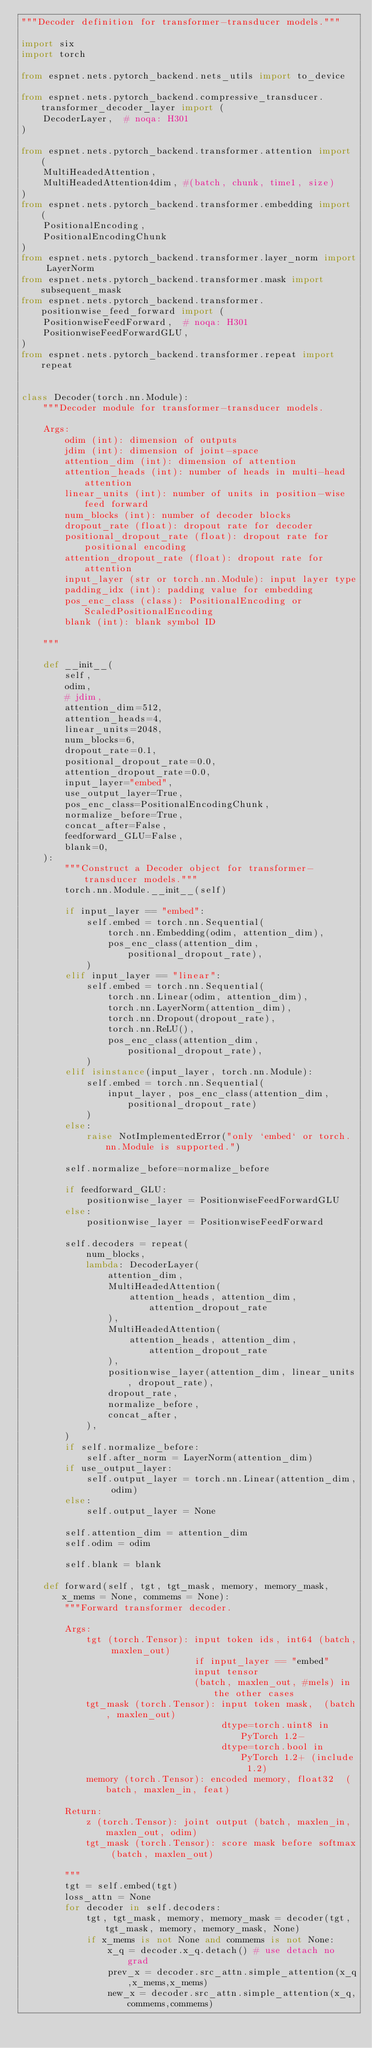<code> <loc_0><loc_0><loc_500><loc_500><_Python_>"""Decoder definition for transformer-transducer models."""

import six
import torch

from espnet.nets.pytorch_backend.nets_utils import to_device

from espnet.nets.pytorch_backend.compressive_transducer.transformer_decoder_layer import (
    DecoderLayer,  # noqa: H301
)

from espnet.nets.pytorch_backend.transformer.attention import (
    MultiHeadedAttention,
    MultiHeadedAttention4dim, #(batch, chunk, time1, size)
)
from espnet.nets.pytorch_backend.transformer.embedding import (
    PositionalEncoding,
    PositionalEncodingChunk
)
from espnet.nets.pytorch_backend.transformer.layer_norm import LayerNorm
from espnet.nets.pytorch_backend.transformer.mask import subsequent_mask
from espnet.nets.pytorch_backend.transformer.positionwise_feed_forward import (
    PositionwiseFeedForward,  # noqa: H301
    PositionwiseFeedForwardGLU,
)
from espnet.nets.pytorch_backend.transformer.repeat import repeat


class Decoder(torch.nn.Module):
    """Decoder module for transformer-transducer models.

    Args:
        odim (int): dimension of outputs
        jdim (int): dimension of joint-space
        attention_dim (int): dimension of attention
        attention_heads (int): number of heads in multi-head attention
        linear_units (int): number of units in position-wise feed forward
        num_blocks (int): number of decoder blocks
        dropout_rate (float): dropout rate for decoder
        positional_dropout_rate (float): dropout rate for positional encoding
        attention_dropout_rate (float): dropout rate for attention
        input_layer (str or torch.nn.Module): input layer type
        padding_idx (int): padding value for embedding
        pos_enc_class (class): PositionalEncoding or ScaledPositionalEncoding
        blank (int): blank symbol ID

    """

    def __init__(
        self,
        odim,
        # jdim,
        attention_dim=512,
        attention_heads=4,
        linear_units=2048,
        num_blocks=6,
        dropout_rate=0.1,
        positional_dropout_rate=0.0,
        attention_dropout_rate=0.0,
        input_layer="embed",
        use_output_layer=True,
        pos_enc_class=PositionalEncodingChunk,
        normalize_before=True,
        concat_after=False,
        feedforward_GLU=False,
        blank=0,
    ):
        """Construct a Decoder object for transformer-transducer models."""
        torch.nn.Module.__init__(self)

        if input_layer == "embed":
            self.embed = torch.nn.Sequential(
                torch.nn.Embedding(odim, attention_dim),
                pos_enc_class(attention_dim, positional_dropout_rate),
            )
        elif input_layer == "linear":
            self.embed = torch.nn.Sequential(
                torch.nn.Linear(odim, attention_dim),
                torch.nn.LayerNorm(attention_dim),
                torch.nn.Dropout(dropout_rate),
                torch.nn.ReLU(),
                pos_enc_class(attention_dim, positional_dropout_rate),
            )
        elif isinstance(input_layer, torch.nn.Module):
            self.embed = torch.nn.Sequential(
                input_layer, pos_enc_class(attention_dim, positional_dropout_rate)
            )
        else:
            raise NotImplementedError("only `embed` or torch.nn.Module is supported.")
        
        self.normalize_before=normalize_before

        if feedforward_GLU:
            positionwise_layer = PositionwiseFeedForwardGLU
        else:
            positionwise_layer = PositionwiseFeedForward

        self.decoders = repeat(
            num_blocks,
            lambda: DecoderLayer(
                attention_dim,
                MultiHeadedAttention(
                    attention_heads, attention_dim, attention_dropout_rate
                ),
                MultiHeadedAttention(
                    attention_heads, attention_dim, attention_dropout_rate
                ),
                positionwise_layer(attention_dim, linear_units, dropout_rate),
                dropout_rate,
                normalize_before,
                concat_after,
            ),
        )
        if self.normalize_before:
            self.after_norm = LayerNorm(attention_dim)
        if use_output_layer:
            self.output_layer = torch.nn.Linear(attention_dim, odim)
        else:
            self.output_layer = None

        self.attention_dim = attention_dim
        self.odim = odim

        self.blank = blank

    def forward(self, tgt, tgt_mask, memory, memory_mask, x_mems = None, commems = None):
        """Forward transformer decoder.

        Args:
            tgt (torch.Tensor): input token ids, int64 (batch, maxlen_out)
                                if input_layer == "embed"
                                input tensor
                                (batch, maxlen_out, #mels) in the other cases
            tgt_mask (torch.Tensor): input token mask,  (batch, maxlen_out)
                                     dtype=torch.uint8 in PyTorch 1.2-
                                     dtype=torch.bool in PyTorch 1.2+ (include 1.2)
            memory (torch.Tensor): encoded memory, float32  (batch, maxlen_in, feat)

        Return:
            z (torch.Tensor): joint output (batch, maxlen_in, maxlen_out, odim)
            tgt_mask (torch.Tensor): score mask before softmax (batch, maxlen_out)

        """
        tgt = self.embed(tgt)
        loss_attn = None
        for decoder in self.decoders:
            tgt, tgt_mask, memory, memory_mask = decoder(tgt, tgt_mask, memory, memory_mask, None) 
            if x_mems is not None and commems is not None:
                x_q = decoder.x_q.detach() # use detach no grad
                prev_x = decoder.src_attn.simple_attention(x_q,x_mems,x_mems)
                new_x = decoder.src_attn.simple_attention(x_q,commems,commems)</code> 